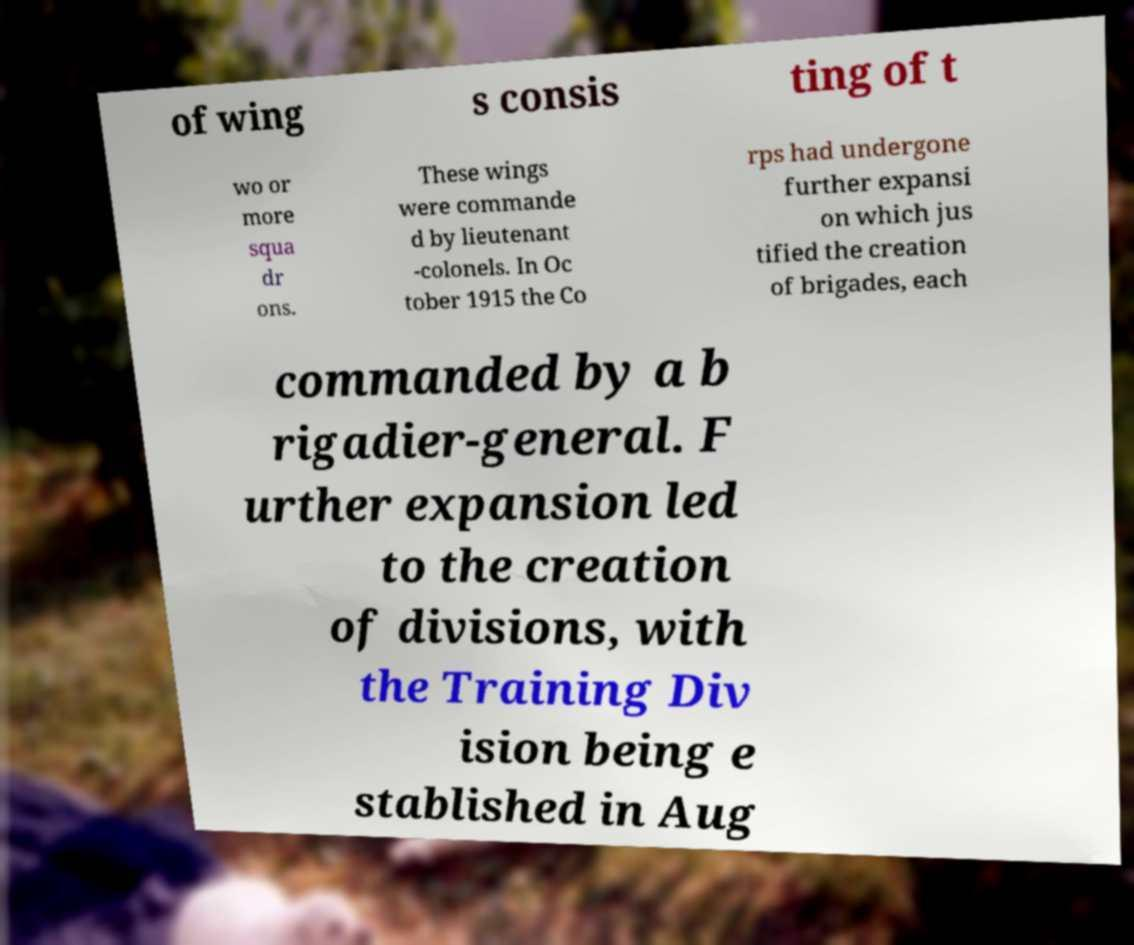Please read and relay the text visible in this image. What does it say? of wing s consis ting of t wo or more squa dr ons. These wings were commande d by lieutenant -colonels. In Oc tober 1915 the Co rps had undergone further expansi on which jus tified the creation of brigades, each commanded by a b rigadier-general. F urther expansion led to the creation of divisions, with the Training Div ision being e stablished in Aug 